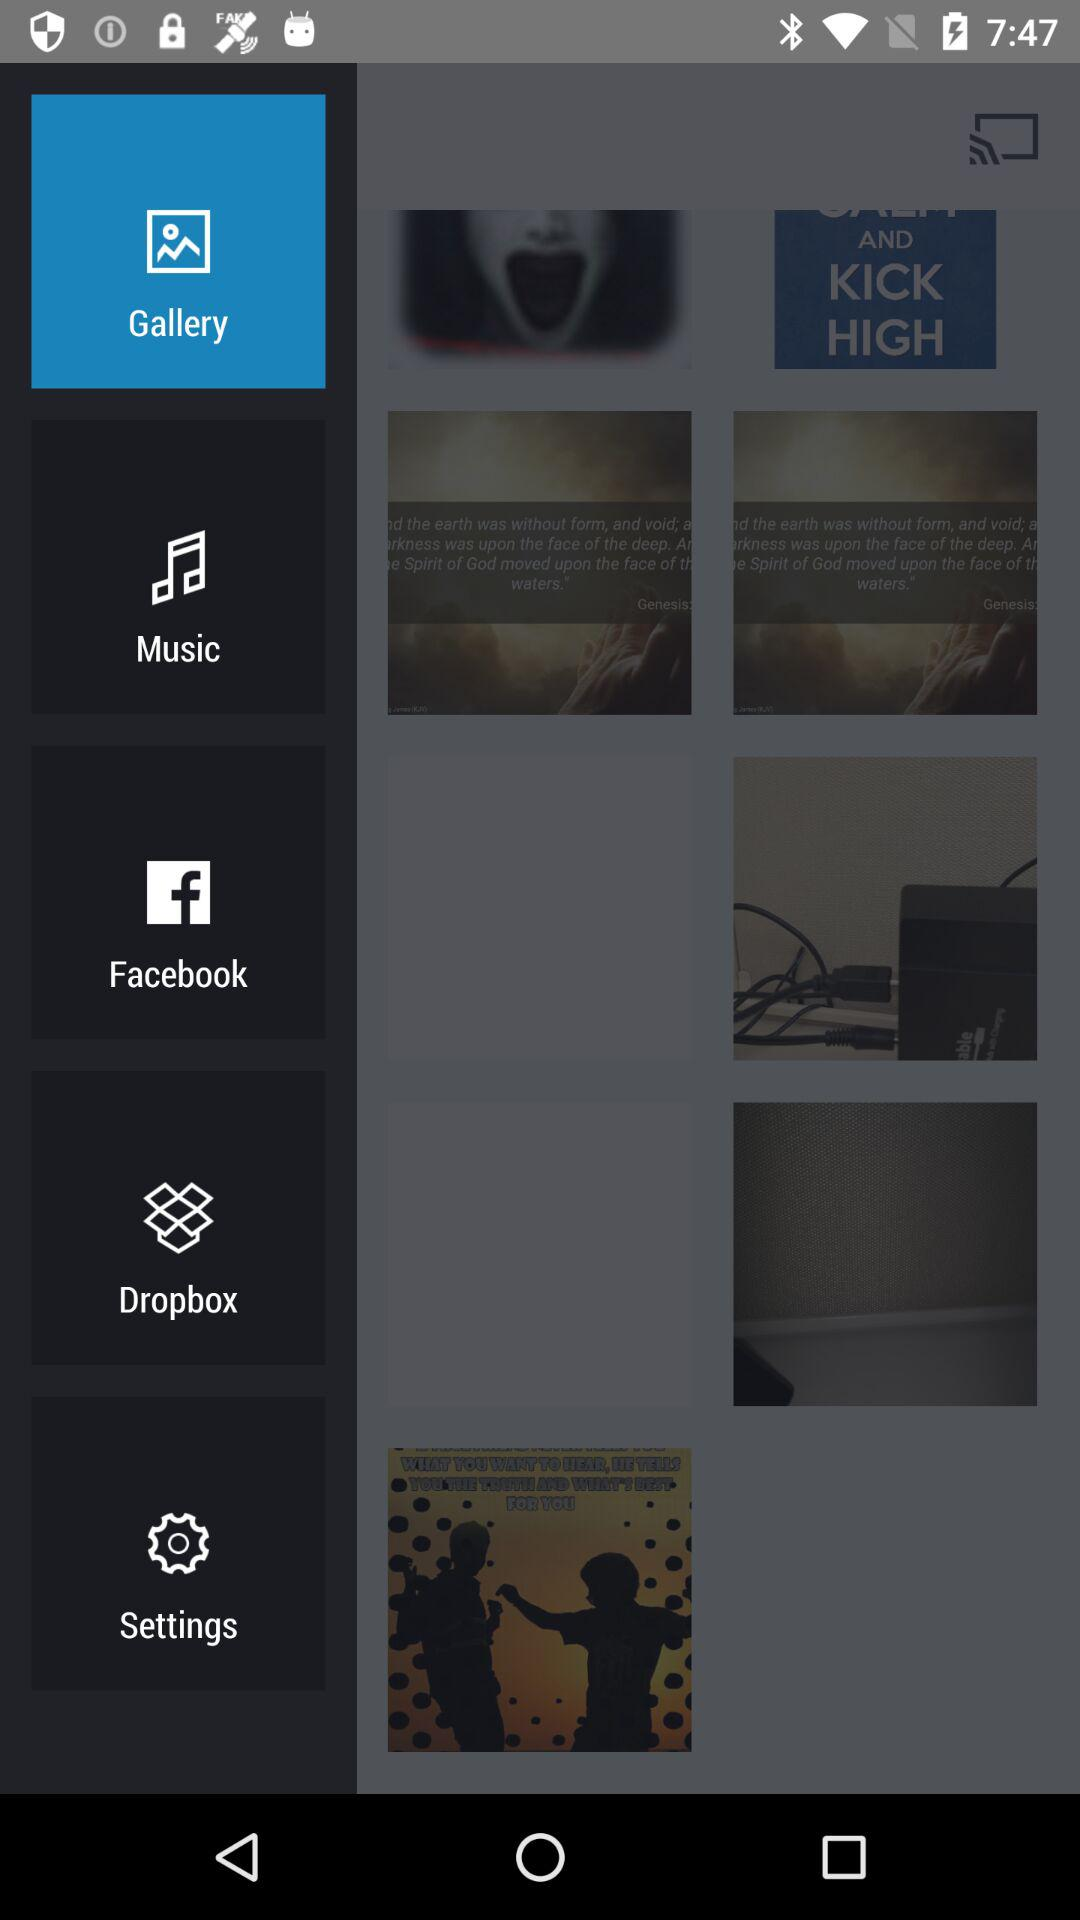Which tab has been selected? The selected tab is "Gallery". 